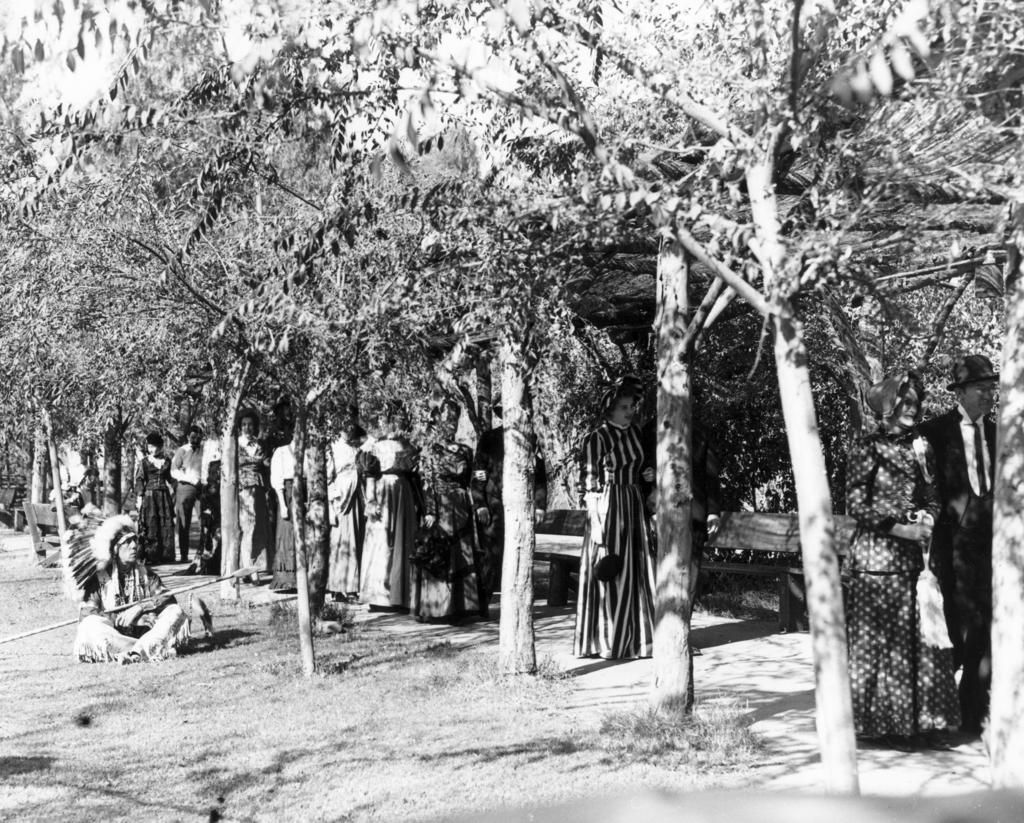What are the people in the image doing? The people in the image are walking. What type of vegetation can be seen in the image? There are trees in the image. Where is the person sitting in the image? The person is sitting on the ground at the left side of the image. What type of boot is the person wearing on their right foot in the image? There is no person wearing a boot in the image; the person sitting on the ground is not wearing any footwear. 